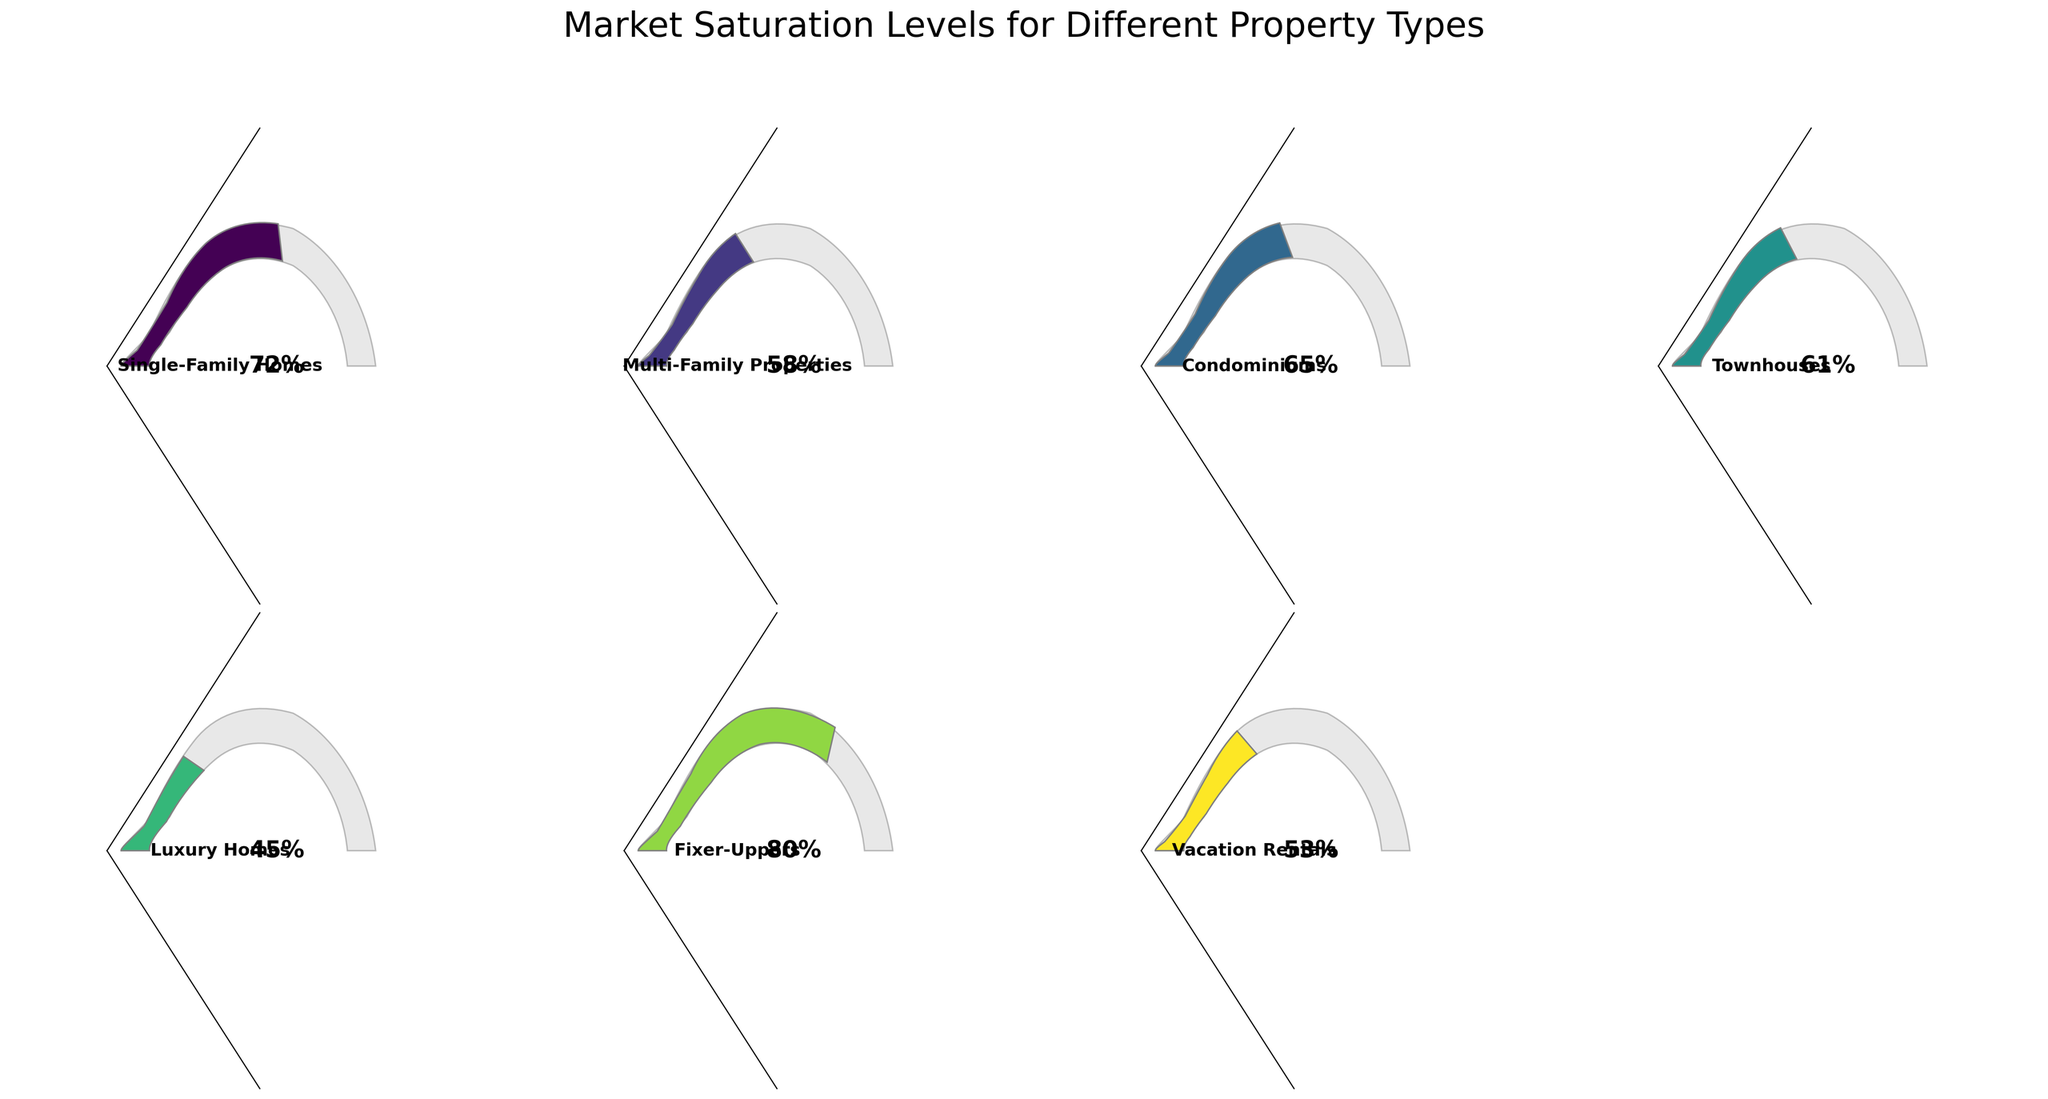What is the market saturation level for Single-Family Homes? The gauge chart for Single-Family Homes shows a saturation level indicator. According to this indicator, the saturation level is visible.
Answer: 72% Which property type has the highest market saturation level? By comparing the saturation levels of all property types, you can identify the one with the highest value. The gauge chart clearly indicates the highest level among the categories.
Answer: Fixer-Uppers What is the difference in market saturation levels between Condominiums and Luxury Homes? Subtract the market saturation level of Luxury Homes from that of Condominiums (65% - 45%).
Answer: 20% How many property types have a market saturation level above 60%? Count the property types with market saturation levels greater than 60% based on the figures provided in the gauge chart.
Answer: 4 Which property type has the lowest market saturation level? Identify the property type with the smallest value on its saturation level indicator.
Answer: Luxury Homes What is the average market saturation level for all the property types? Add all the market saturation levels and divide by the number of property types {(72 + 58 + 65 + 61 + 45 + 80 + 53) / 7}.
Answer: 62% Does Multi-Family Properties have a higher market saturation level than Vacation Rentals? Compare the saturation levels: Multi-Family Properties (58%) vs. Vacation Rentals (53%).
Answer: Yes By how much does the market saturation level of Townhouses exceed that of Luxury Homes? Subtract the market saturation level of Luxury Homes from that of Townhouses (61% - 45%).
Answer: 16% Which property type has a market saturation level closest to 50%? Compare all saturation levels and find the one nearest to 50%. The closest level is identified from the gauge charts.
Answer: Vacation Rentals Are there more property types with market saturation levels above or below 60%? Count the number of property types above 60% and those below 60%, then compare these counts.
Answer: Above 